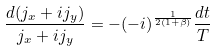Convert formula to latex. <formula><loc_0><loc_0><loc_500><loc_500>\frac { d ( j _ { x } + i j _ { y } ) } { j _ { x } + i j _ { y } } = - ( - i ) ^ { \frac { 1 } { 2 ( 1 + \beta ) } } \frac { d t } { T }</formula> 